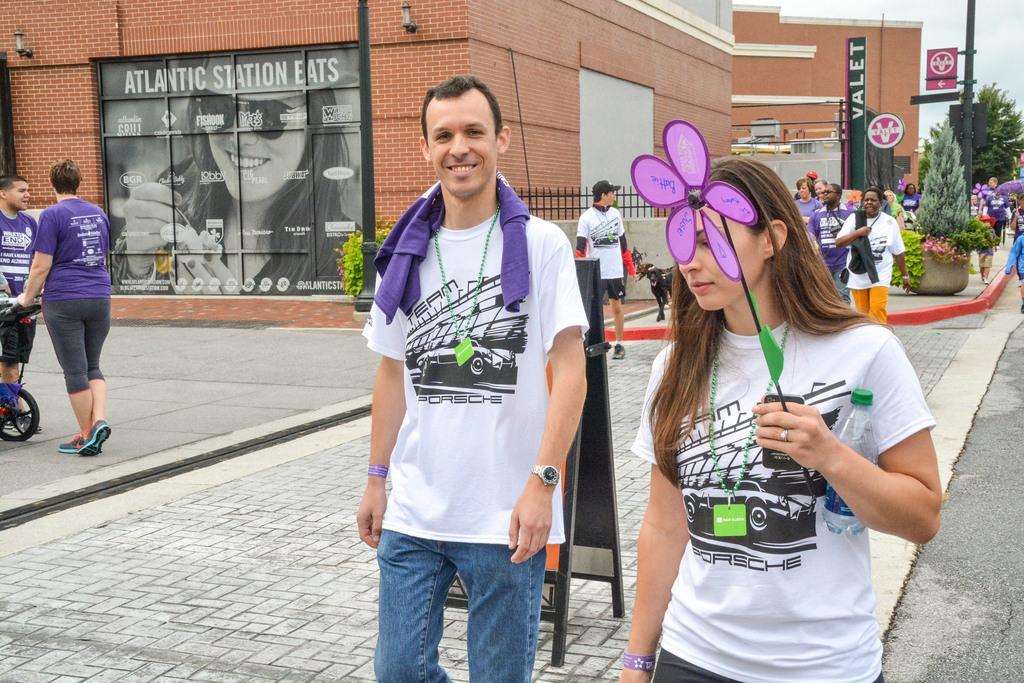Can you describe this image briefly? In the picture I can see people standing on the ground. In the background I can see buildings, trees, plants, lights on the wall and some other objects. I can also see the sky. 